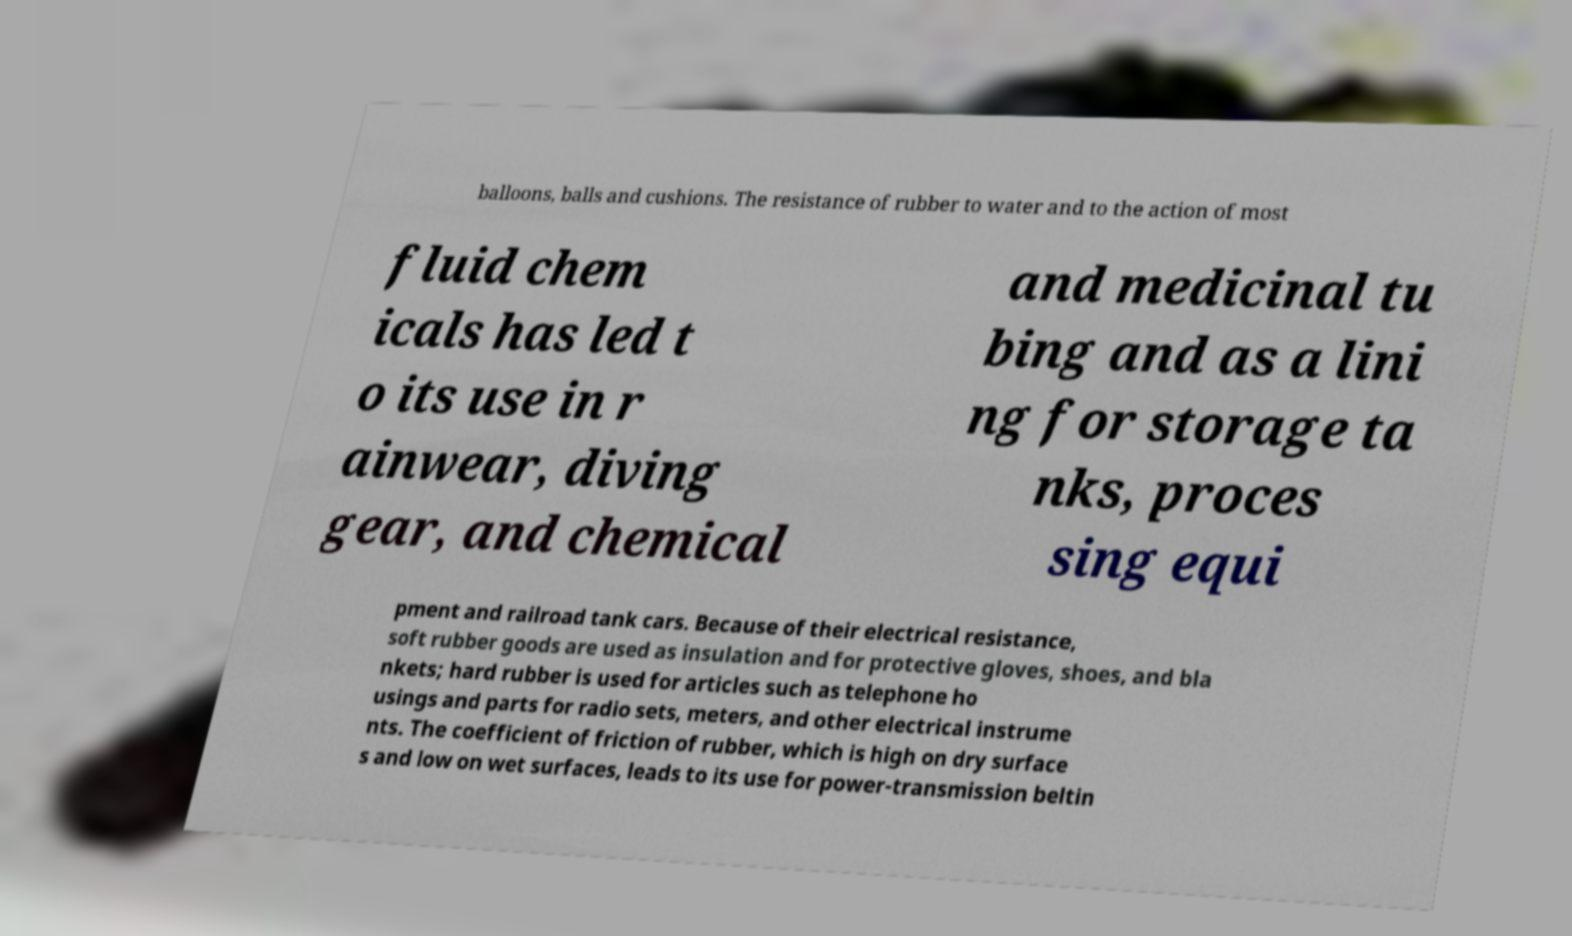What messages or text are displayed in this image? I need them in a readable, typed format. balloons, balls and cushions. The resistance of rubber to water and to the action of most fluid chem icals has led t o its use in r ainwear, diving gear, and chemical and medicinal tu bing and as a lini ng for storage ta nks, proces sing equi pment and railroad tank cars. Because of their electrical resistance, soft rubber goods are used as insulation and for protective gloves, shoes, and bla nkets; hard rubber is used for articles such as telephone ho usings and parts for radio sets, meters, and other electrical instrume nts. The coefficient of friction of rubber, which is high on dry surface s and low on wet surfaces, leads to its use for power-transmission beltin 